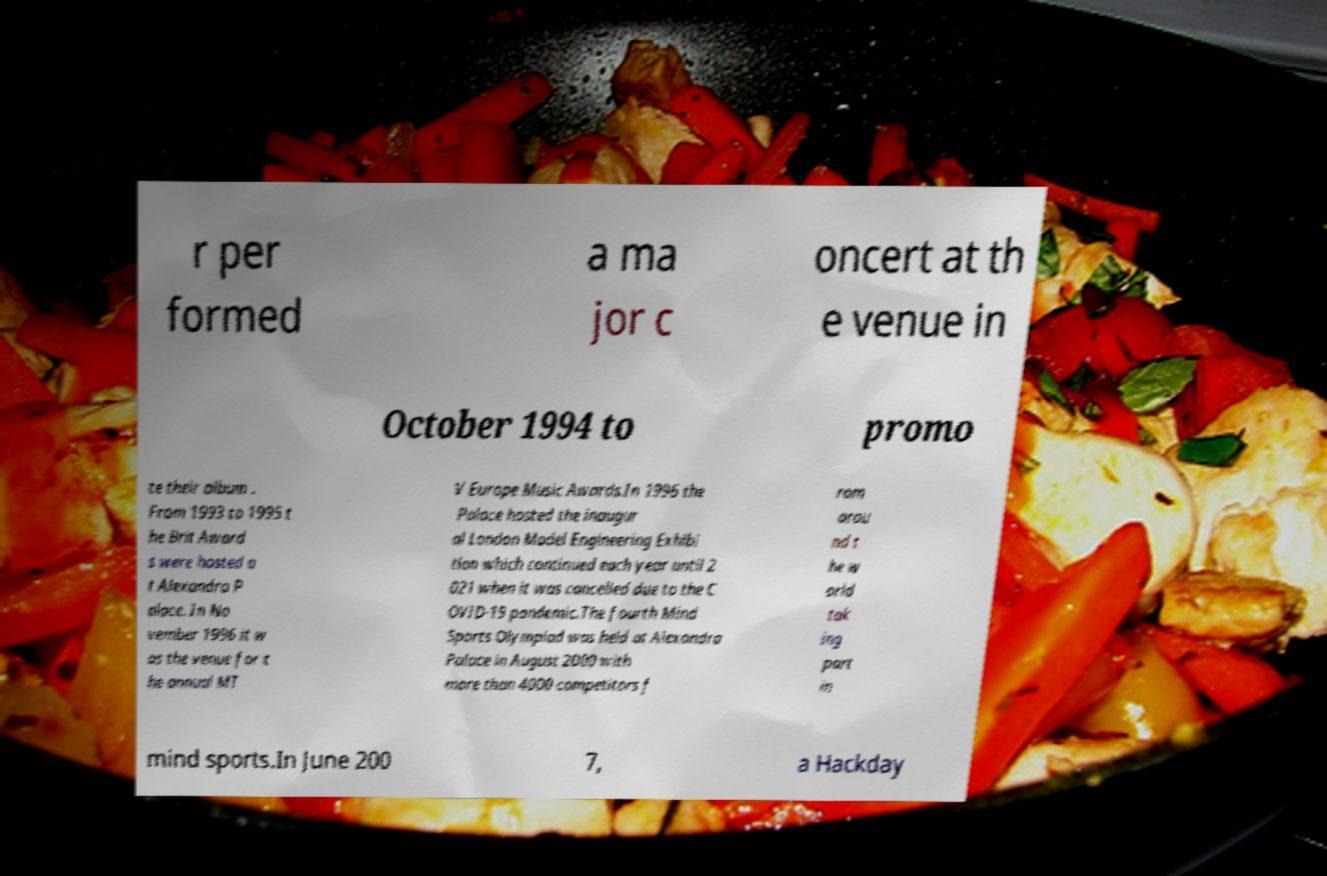Can you accurately transcribe the text from the provided image for me? r per formed a ma jor c oncert at th e venue in October 1994 to promo te their album . From 1993 to 1995 t he Brit Award s were hosted a t Alexandra P alace. In No vember 1996 it w as the venue for t he annual MT V Europe Music Awards.In 1996 the Palace hosted the inaugur al London Model Engineering Exhibi tion which continued each year until 2 021 when it was cancelled due to the C OVID-19 pandemic.The fourth Mind Sports Olympiad was held at Alexandra Palace in August 2000 with more than 4000 competitors f rom arou nd t he w orld tak ing part in mind sports.In June 200 7, a Hackday 